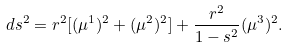<formula> <loc_0><loc_0><loc_500><loc_500>d s ^ { 2 } = r ^ { 2 } [ ( \mu ^ { 1 } ) ^ { 2 } + ( \mu ^ { 2 } ) ^ { 2 } ] + \frac { r ^ { 2 } } { 1 - s ^ { 2 } } ( \mu ^ { 3 } ) ^ { 2 } .</formula> 